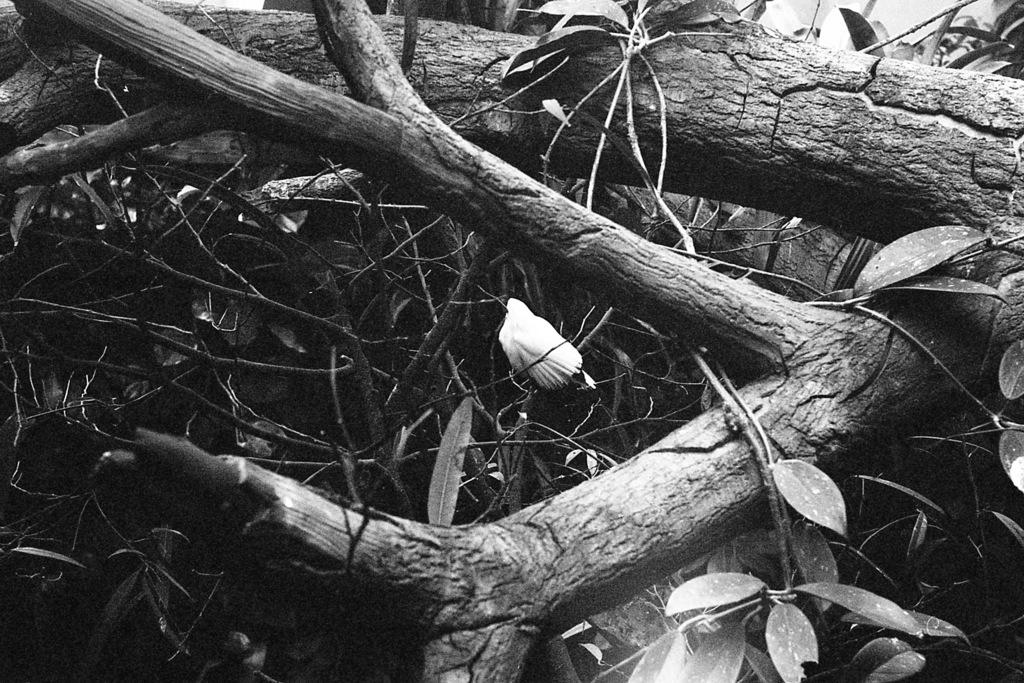What is the color scheme of the image? The image is black and white. What type of vegetation can be seen in the image? There are branches with leaves in the image. What activity is taking place at 3 o'clock in the image? There is no activity or time reference in the image, as it only features branches with leaves in a black and white color scheme. 